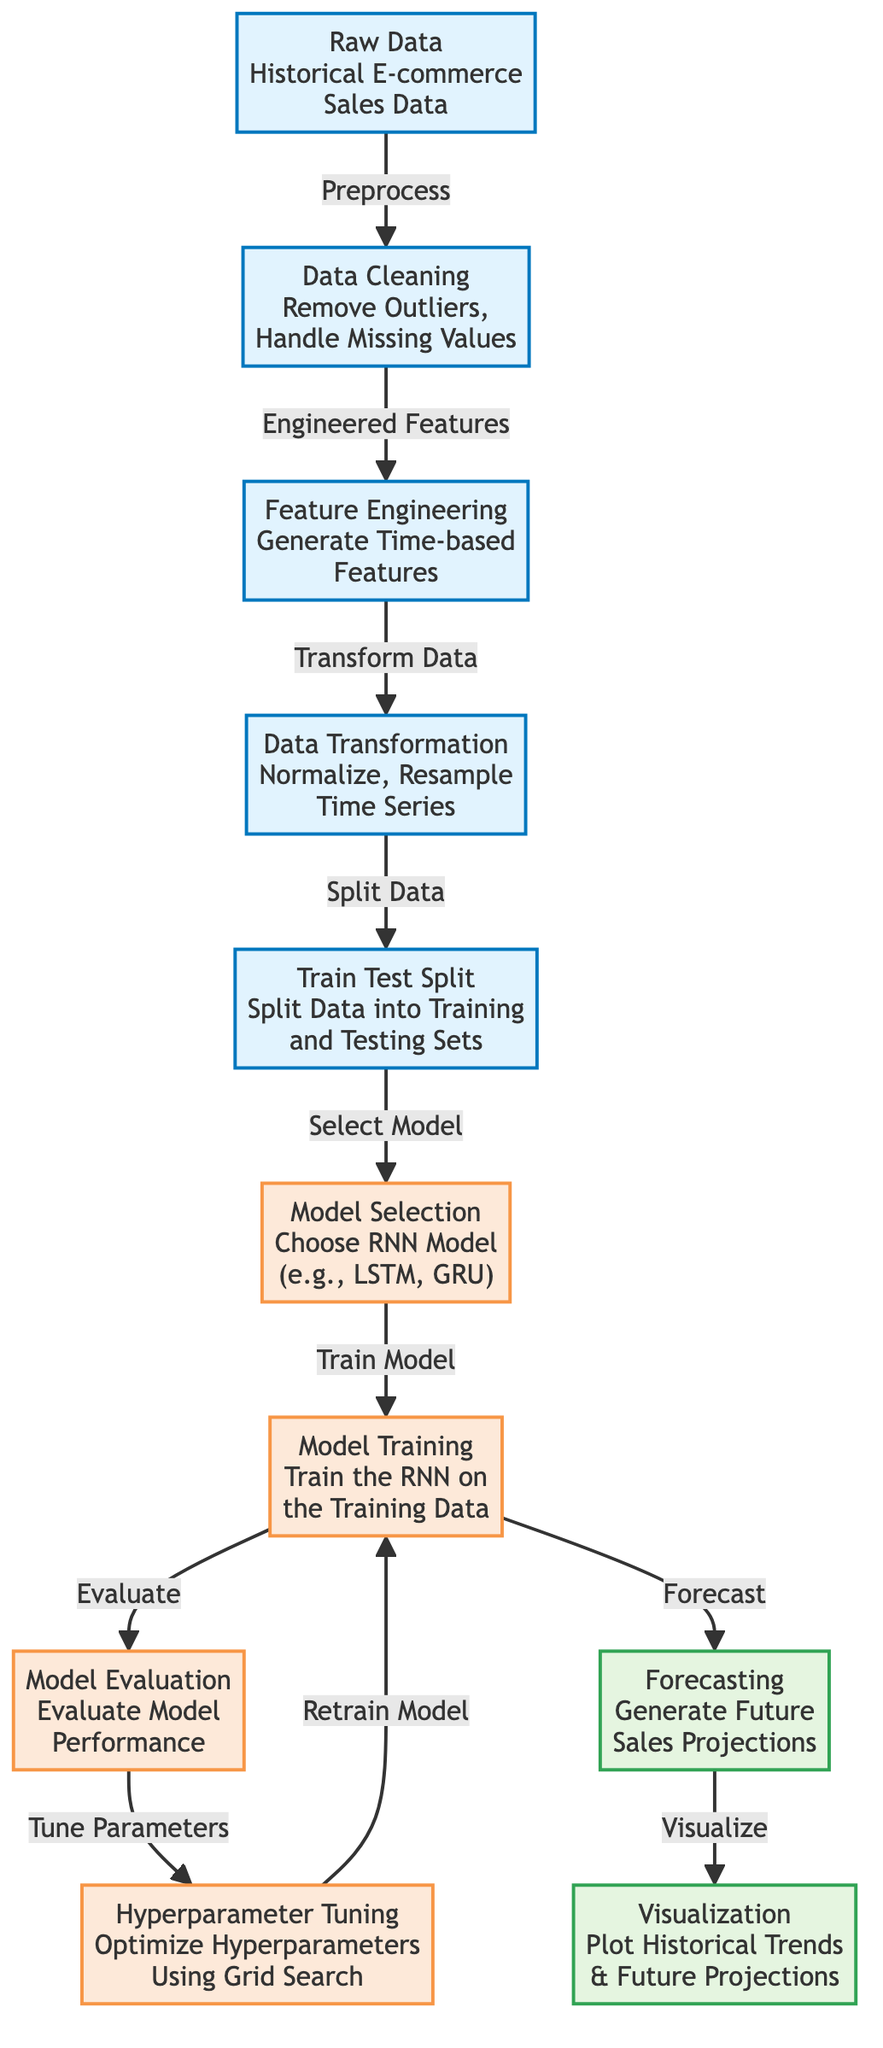What is the first step in the diagram? The first step indicated in the diagram is "Raw Data", which represents the initial input of historical e-commerce sales data before any processing occurs.
Answer: Raw Data How many main processes are shown in the diagram? The diagram includes five main processes which are represented by the nodes categorized under the class "process". These nodes include Raw Data, Data Cleaning, Feature Engineering, Data Transformation, and Train Test Split.
Answer: Five Which node represents the model evaluation step? The node labeled "Model Evaluation" signifies the process of evaluating the performance of the machine learning model after it has been trained.
Answer: Model Evaluation What follows the model training step? Based on the flow of the diagram, "Model Evaluation" is the next step that follows "Model Training," indicating the assessment of the model's performance.
Answer: Model Evaluation How does the data transition from model selection to training? The transition from "Model Selection" to "Model Training" occurs after choosing a recurrent neural network model, signaling that the model is selected for training.
Answer: Train Model What type of output is generated after the forecasting step? "Visualization" is the output generated after the "Forecasting" step, displaying plots of historical trends and future projections of sales.
Answer: Visualization Describe the type of model selected in the diagram. The diagram specifies that a recurrent neural network (RNN) will be chosen as the model type, highlighting options like LSTM or GRU for e-commerce sales forecasting.
Answer: RNN Which node incorporates hyperparameter optimization? The "Hyperparameter Tuning" node is specifically dedicated to optimizing hyperparameters, ensuring the model performs optimally before final training.
Answer: Hyperparameter Tuning What is the relationship between data cleaning and feature engineering? Data cleaning produces engineered features that are then used in the subsequent step of feature engineering, indicating that cleaned data feeds into feature creation.
Answer: Engineered Features 